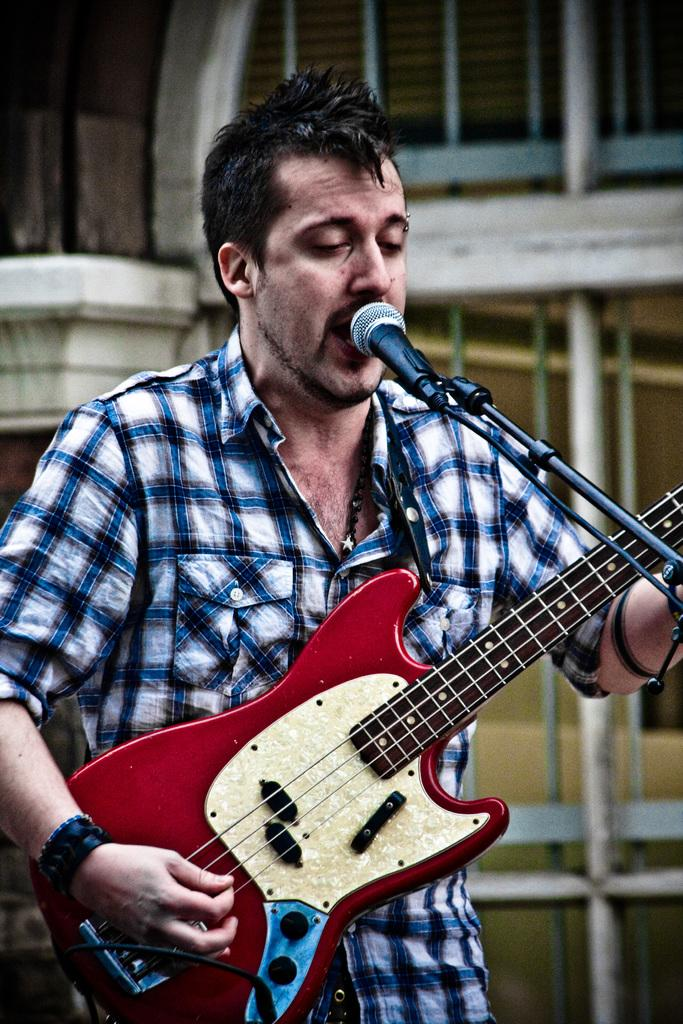What is the person in the image doing? The person is singing a song. What object is the person holding while singing? The person is holding a microphone. Where is the microphone positioned in relation to the person? The microphone is in front of the person. What other musical instrument is the person holding? The person is holding a guitar. What type of garden can be seen in the background of the image? There is no garden present in the image; it features a person singing with a microphone and guitar. 